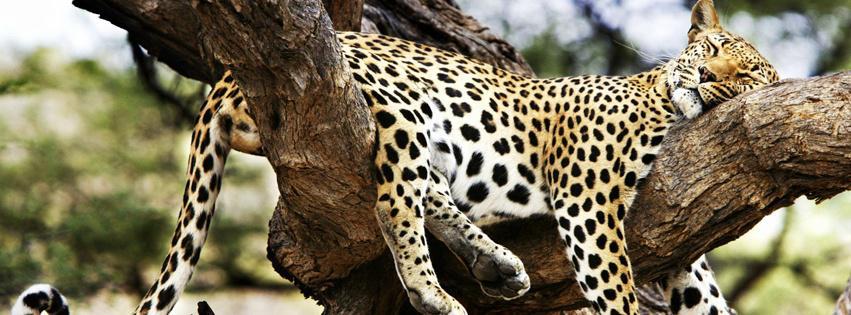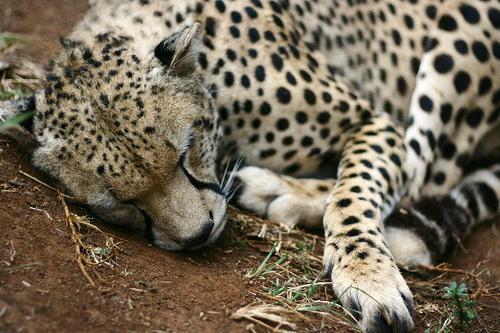The first image is the image on the left, the second image is the image on the right. Evaluate the accuracy of this statement regarding the images: "There are at most 2 cheetahs in the image pair". Is it true? Answer yes or no. Yes. The first image is the image on the left, the second image is the image on the right. Given the left and right images, does the statement "Each image shows a single cheetah." hold true? Answer yes or no. Yes. 